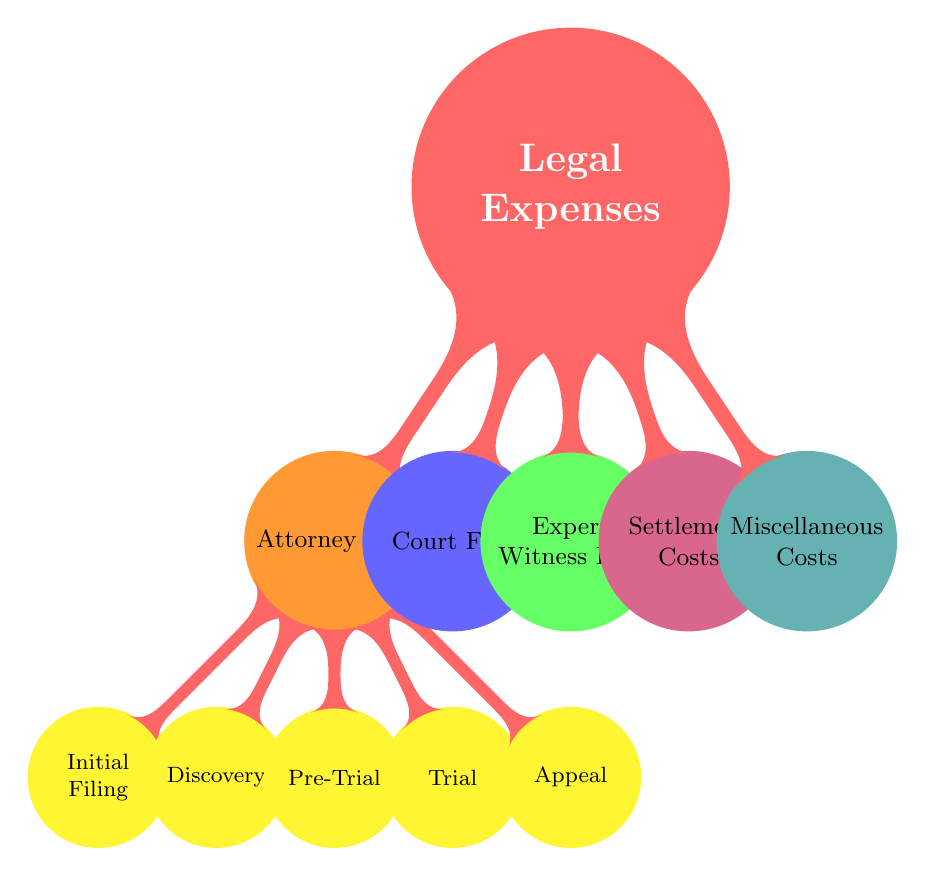What are the main categories of legal expenses in the diagram? The diagram divides legal expenses into four main categories: Attorney Fees, Court Fees, Expert Witness Fees, Settlement Costs, and Miscellaneous Costs.
Answer: Attorney Fees, Court Fees, Expert Witness Fees, Settlement Costs, Miscellaneous Costs How many subcategories are there under Attorney Fees? The Attorney Fees category has five subcategories: Initial Filing, Discovery, Pre-Trial, Trial, and Appeal. By counting these, we find there are a total of five subcategories.
Answer: 5 Which type of cost is the only one without subcategories? The diagram shows that Court Fees is the only type of cost that does not have any listed subcategories beneath it, indicating that it is a standalone cost type.
Answer: Court Fees Which subcategory under Attorney Fees comes last in the hierarchy? The last subcategory listed under Attorney Fees is Appeal. This is determined by looking at the order of the child nodes stemming from Attorney Fees.
Answer: Appeal Which category is colored purple in the diagram? The category colored purple in the diagram represents Settlement Costs. The diagram's color coding allows for quick identification of each cost type by its associated color.
Answer: Settlement Costs What is the total number of nodes in the diagram? To find the total number of nodes, we count the root node (Legal Expenses), the main categories (4), and the subcategories under Attorney Fees (5). Adding these gives a total of 10 nodes.
Answer: 10 Which category includes Initial Filing as a subcategory? The Initial Filing subcategory is included in the Attorney Fees category. This can be confirmed by tracing the connection from the root node down to the specific subcategory.
Answer: Attorney Fees Which two categories are in blue and green colors respectively? The blue category is Court Fees and the green category is Expert Witness Fees. This can be observed by examining the color attributes assigned to each category node in the diagram.
Answer: Court Fees, Expert Witness Fees How many child nodes are there in total for the root node labeled Legal Expenses? The root node labeled Legal Expenses has a total of five child nodes: Attorney Fees, Court Fees, Expert Witness Fees, Settlement Costs, and Miscellaneous Costs. Adding up these categories gives the total of five.
Answer: 5 